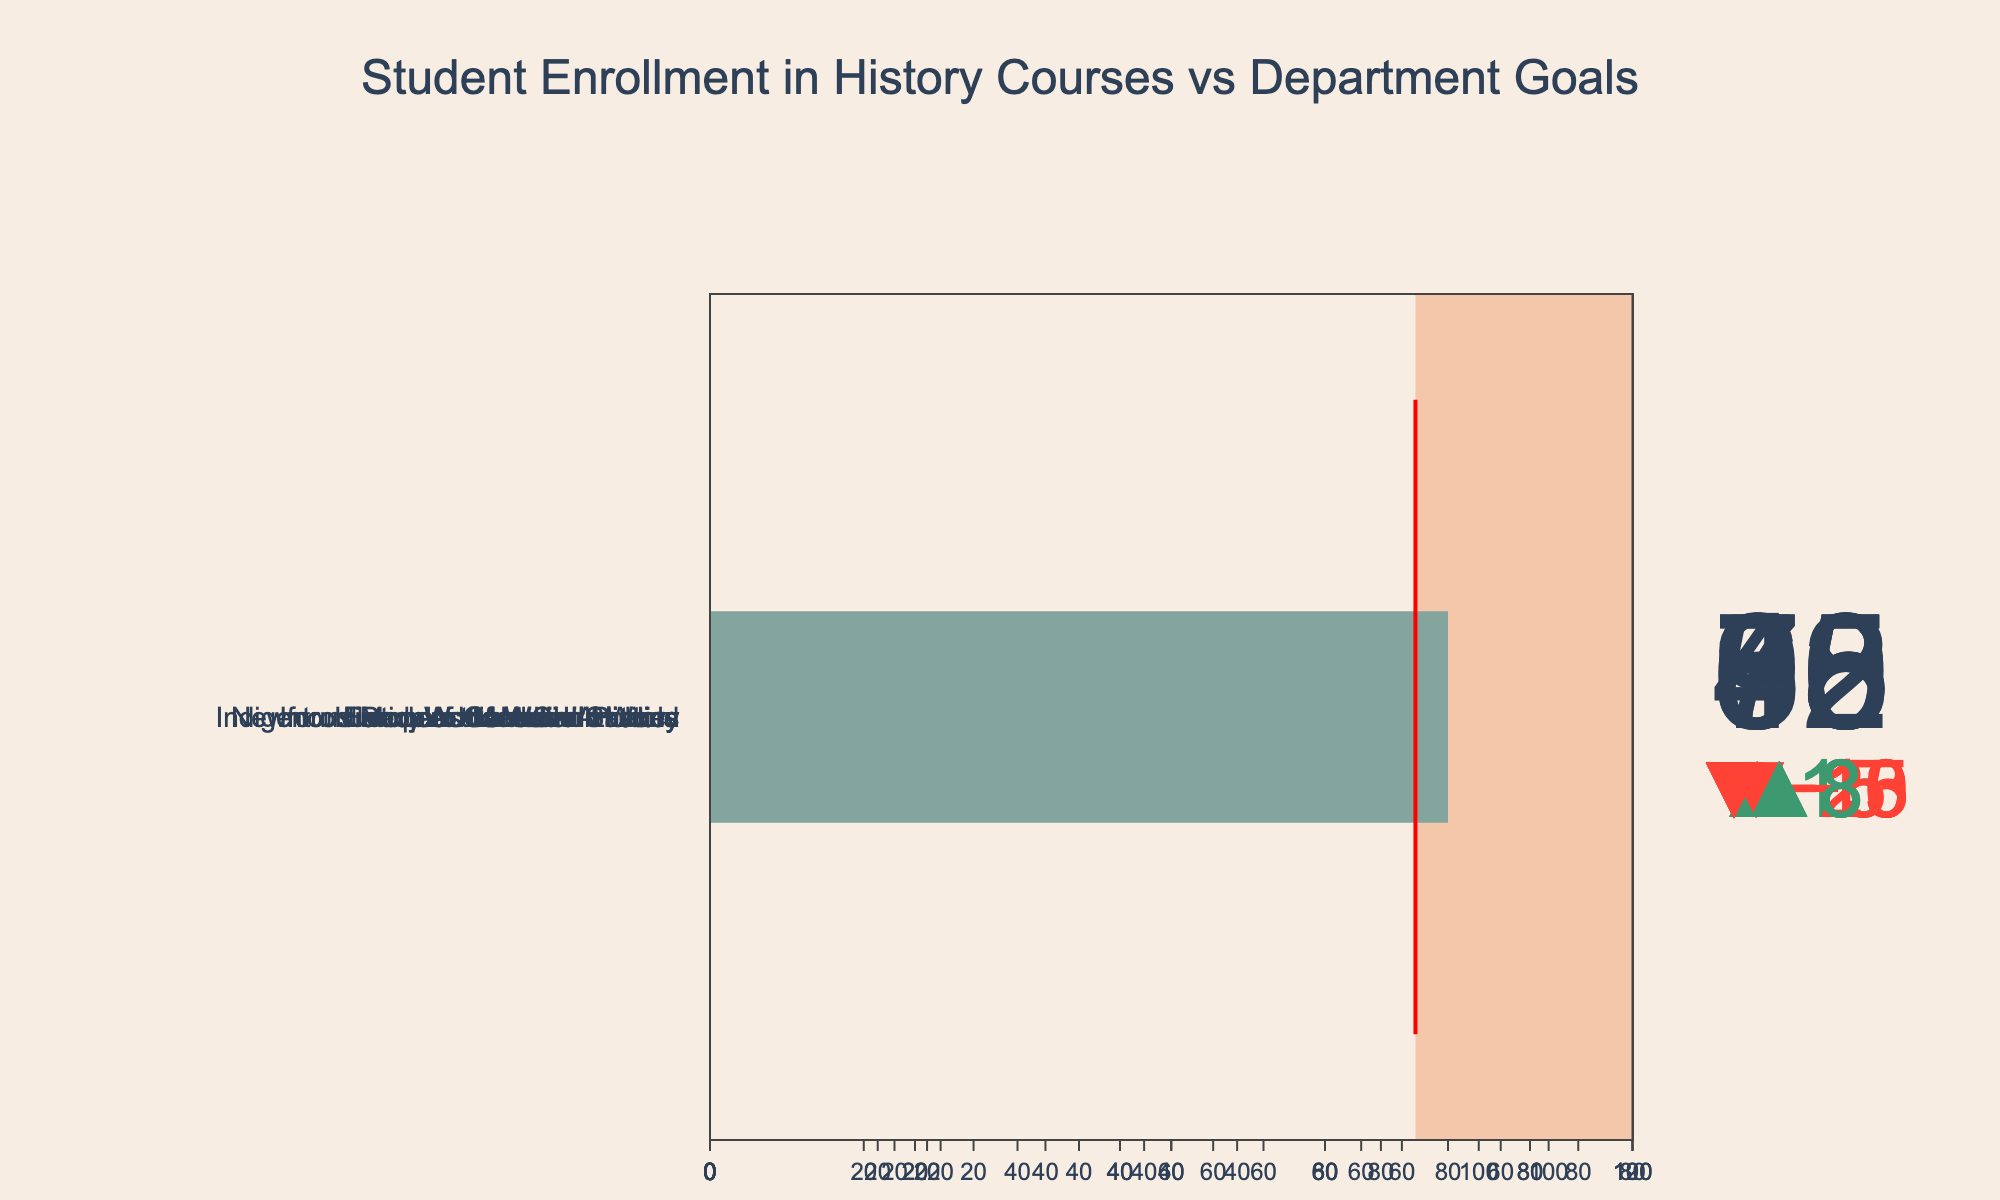What course has the highest actual enrollment? Scan the bullet chart for the course with the highest value in the Actual Enrollment section. The course with 95 students enrolled is World War II Studies.
Answer: World War II Studies Which course's actual enrollment surpassed its goal by the largest margin? Compare the difference between Actual Enrollment and Goal for each course. World War II Studies has 95 actual enrollments and an 80-student goal, a surplus of 15.
Answer: World War II Studies How many courses did not meet their enrollment goals? Check each course to see if Actual Enrollment is less than the Goal. There are five courses: Introduction to Canadian History, Newfoundland and Labrador History, Indigenous Peoples of North America, European Medieval History, and History of the Atlantic World.
Answer: 5 Which course had a goal closest to its actual enrollment? Calculate the absolute difference between Actual Enrollment and Goal for each course. Ancient Civilizations had an actual enrollment of 68 and a goal of 65, a difference of 3, which is the smallest.
Answer: Ancient Civilizations What is the total maximum capacity of all courses combined? Sum the Maximum Capacity values for all courses: 120 + 90 + 100 + 110 + 80 + 70 + 90 + 85 = 745.
Answer: 745 Which course's actual enrollment is closest to its maximum capacity? Calculate the difference between Actual Enrollment and Maximum Capacity for each course. World War II Studies had an actual enrollment of 95 and a max capacity of 100, a difference of 5, which is the closest.
Answer: World War II Studies How many courses exceeded their enrollment goals? Check each course to see if Actual Enrollment is greater than the Goal. There are three courses: World War II Studies, Modern Canadian Politics, and Ancient Civilizations.
Answer: 3 What is the average actual enrollment of all courses? Sum the Actual Enrollment values and divide by the number of courses: (85 + 62 + 95 + 70 + 55 + 40 + 78 + 68) / 8 = 553 / 8 = 69.125.
Answer: 69.125 Which course has the largest enrollment shortfall relative to its goal? Calculate the shortfall (Goal - Actual Enrollment) for each course. Indigenous Peoples of North America has a goal of 90 and an actual enrollment of 70, a shortfall of 20, which is the largest.
Answer: Indigenous Peoples of North America 